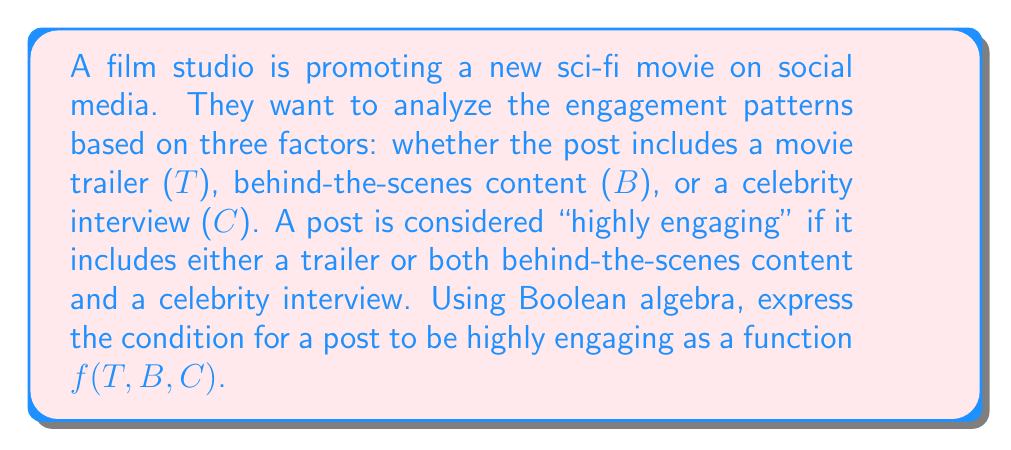What is the answer to this math problem? Let's approach this step-by-step:

1) We need to create a Boolean function $f(T,B,C)$ where:
   - $T$: post includes a trailer
   - $B$: post includes behind-the-scenes content
   - $C$: post includes a celebrity interview

2) The post is highly engaging if:
   - It includes a trailer (T)
   OR
   - It includes both behind-the-scenes content (B) AND a celebrity interview (C)

3) In Boolean algebra, we can express this as:
   $f(T,B,C) = T + (B \cdot C)$

   Where:
   - $+$ represents the OR operation
   - $\cdot$ represents the AND operation

4) This function will output 1 (true) if:
   - $T$ is 1 (trailer is included)
   - OR if both $B$ and $C$ are 1 (both behind-the-scenes and celebrity interview are included)

5) In all other cases, the function will output 0 (false), indicating the post is not highly engaging according to the given criteria.

This Boolean function effectively models the described engagement pattern for movie promotions on social media.
Answer: $f(T,B,C) = T + (B \cdot C)$ 